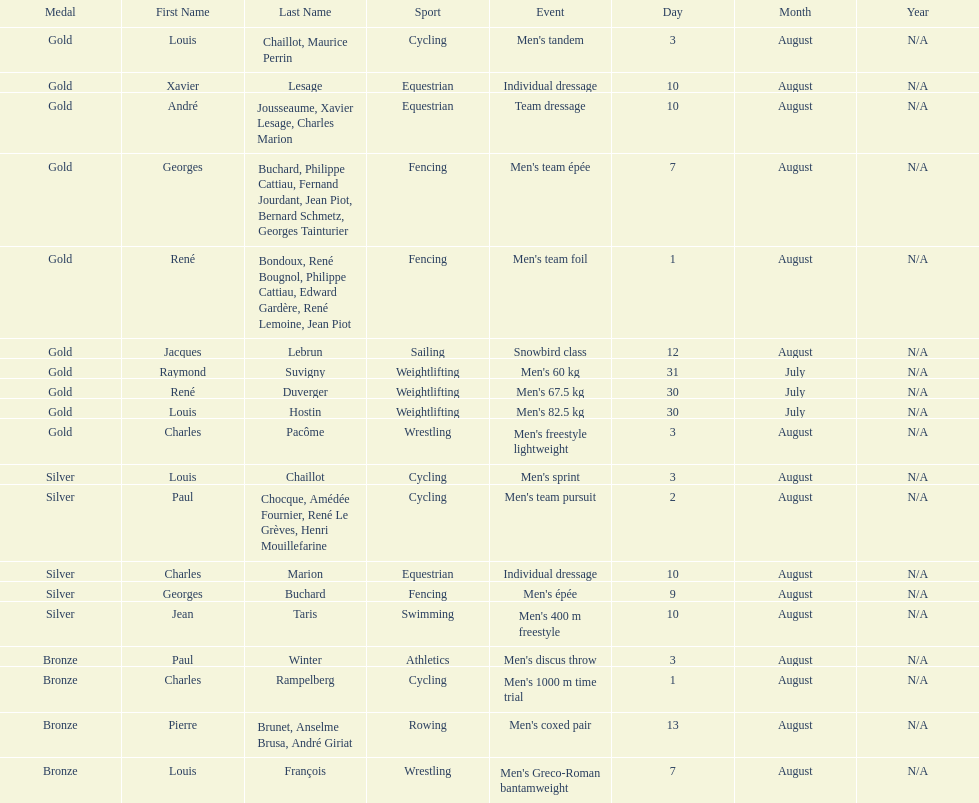What event is listed right before team dressage? Individual dressage. 